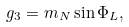Convert formula to latex. <formula><loc_0><loc_0><loc_500><loc_500>g _ { 3 } = m _ { N } \sin \Phi _ { L } ,</formula> 